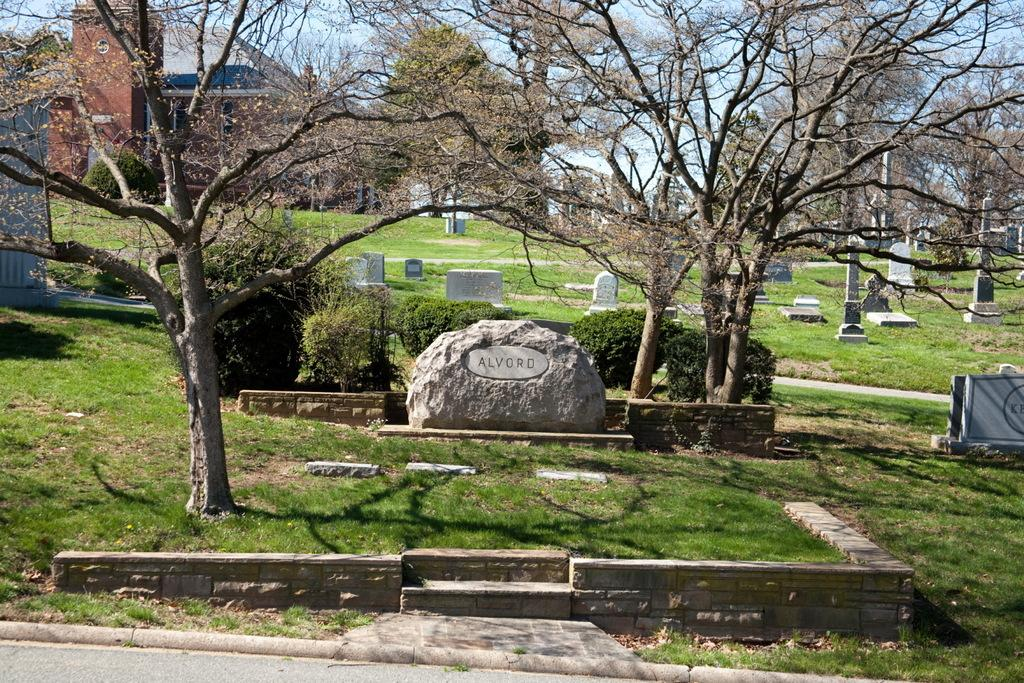What type of structures can be seen in the image? There are tombstones in the image. What type of vegetation is present in the image? There are plants, trees, and grass in the image. What can be seen in the background of the image? There are buildings and the sky visible in the background of the image. Are there any shadows present in the image? Yes, shadows are present in the image. Can you see any animals from the zoo in the image? There is no zoo present in the image, so no animals from a zoo can be seen. Are there any icicles hanging from the trees in the image? There are no icicles present in the image; it appears to be a warm and sunny day. 